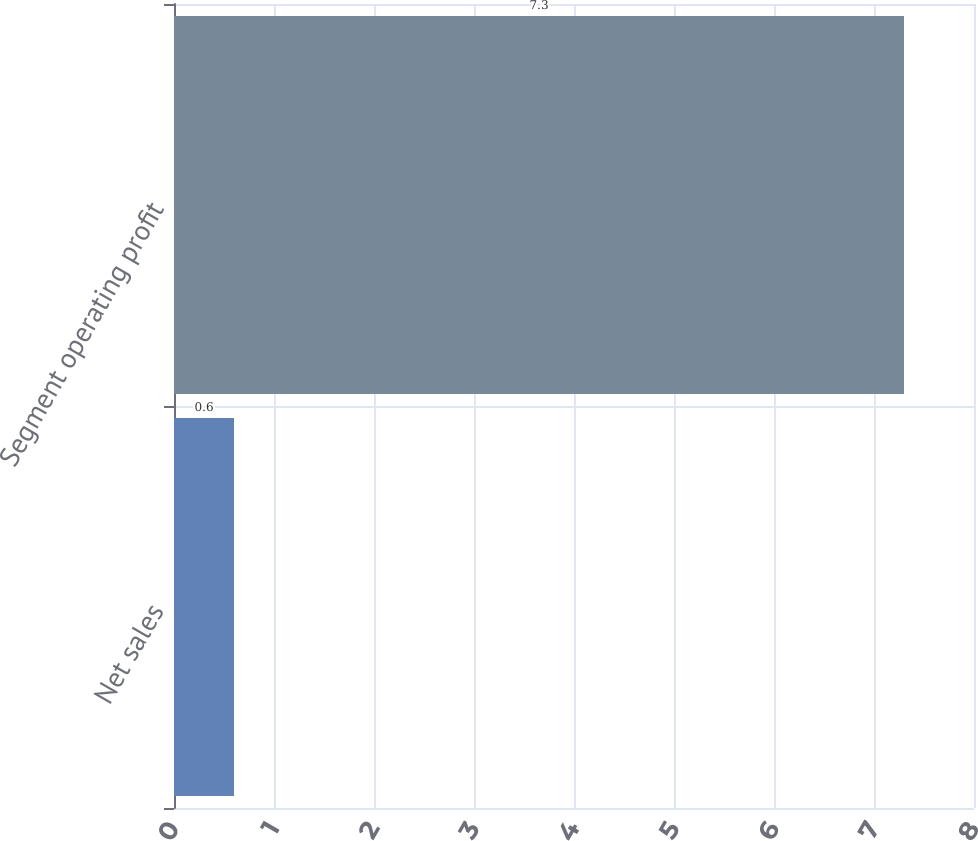Convert chart. <chart><loc_0><loc_0><loc_500><loc_500><bar_chart><fcel>Net sales<fcel>Segment operating profit<nl><fcel>0.6<fcel>7.3<nl></chart> 